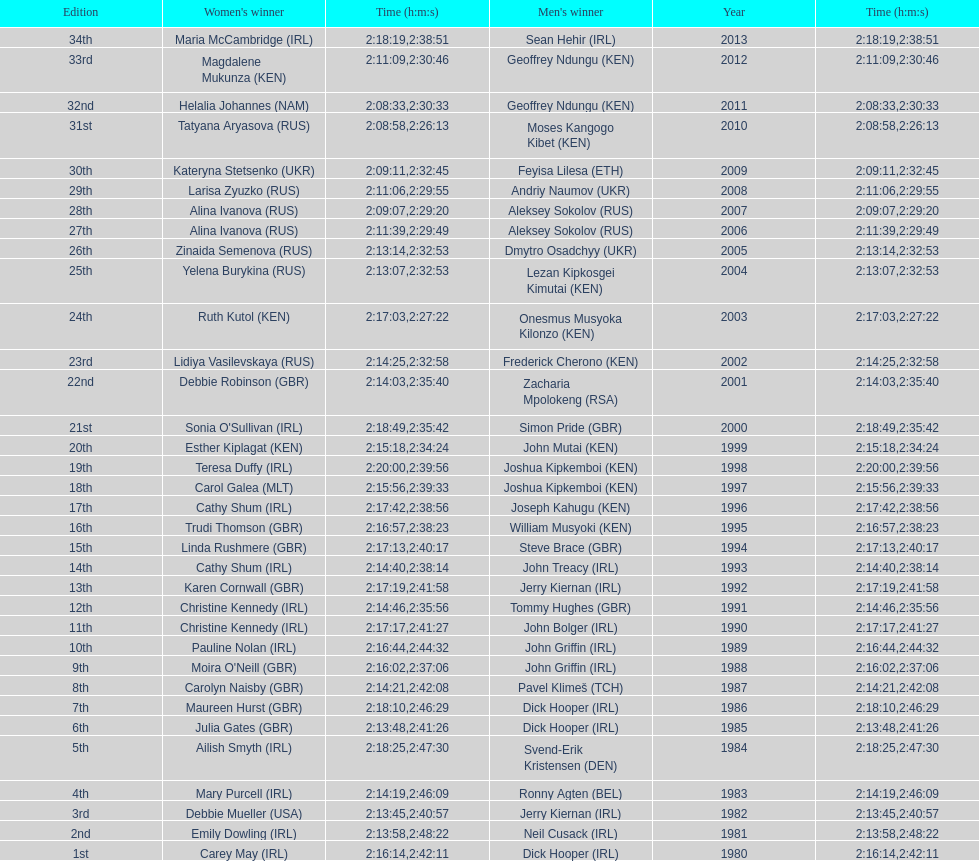Who won after joseph kipkemboi's winning streak ended? John Mutai (KEN). 